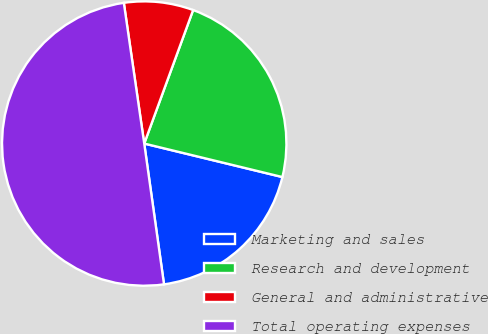Convert chart. <chart><loc_0><loc_0><loc_500><loc_500><pie_chart><fcel>Marketing and sales<fcel>Research and development<fcel>General and administrative<fcel>Total operating expenses<nl><fcel>18.99%<fcel>23.2%<fcel>7.88%<fcel>49.93%<nl></chart> 